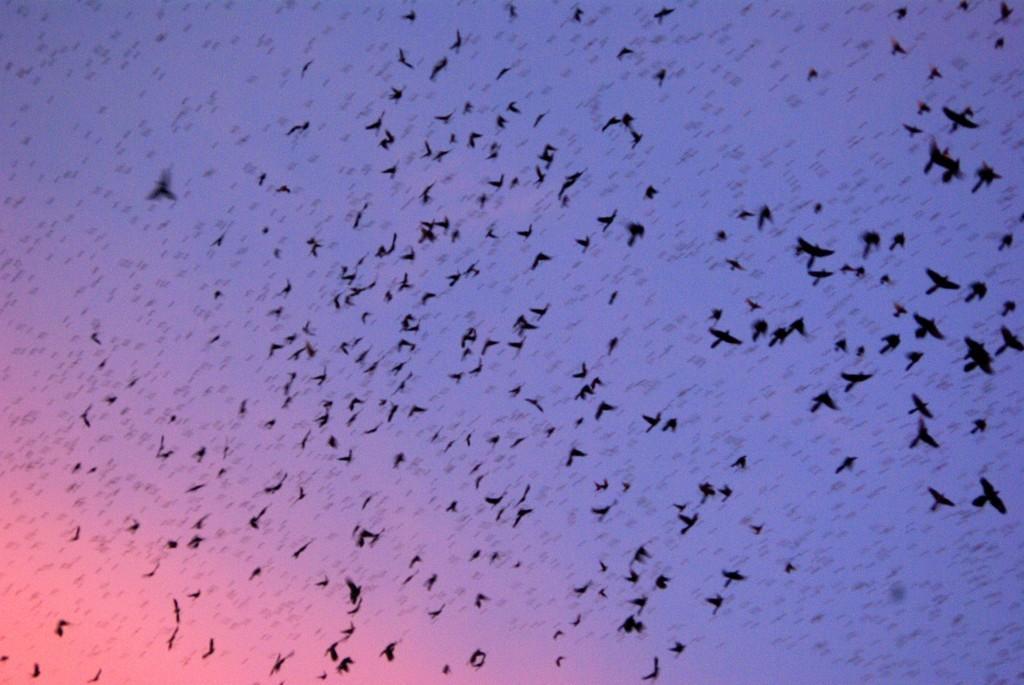Can you describe this image briefly? In this picture, we see birds flying in the sky. In the background, we see the sky, which is blue in color. In the left bottom of the picture, we see the sky, which is orange in color. 